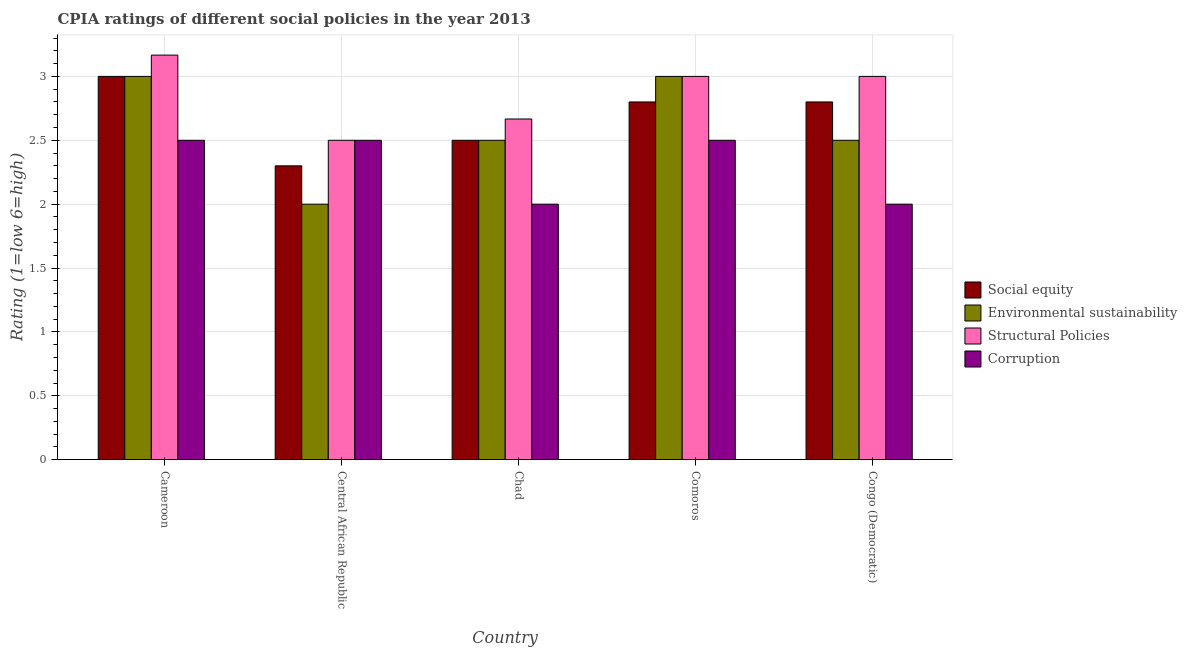How many bars are there on the 3rd tick from the left?
Provide a short and direct response. 4. What is the label of the 3rd group of bars from the left?
Provide a short and direct response. Chad. In how many cases, is the number of bars for a given country not equal to the number of legend labels?
Provide a short and direct response. 0. What is the cpia rating of corruption in Chad?
Keep it short and to the point. 2. In which country was the cpia rating of environmental sustainability maximum?
Offer a very short reply. Cameroon. In which country was the cpia rating of structural policies minimum?
Your response must be concise. Central African Republic. What is the total cpia rating of structural policies in the graph?
Provide a short and direct response. 14.33. What is the difference between the cpia rating of environmental sustainability in Cameroon and that in Congo (Democratic)?
Your answer should be compact. 0.5. What is the difference between the cpia rating of structural policies in Central African Republic and the cpia rating of social equity in Congo (Democratic)?
Make the answer very short. -0.3. What is the average cpia rating of structural policies per country?
Offer a very short reply. 2.87. What is the ratio of the cpia rating of social equity in Cameroon to that in Congo (Democratic)?
Provide a short and direct response. 1.07. Is the difference between the cpia rating of structural policies in Cameroon and Comoros greater than the difference between the cpia rating of social equity in Cameroon and Comoros?
Provide a succinct answer. No. What is the difference between the highest and the second highest cpia rating of structural policies?
Ensure brevity in your answer.  0.17. What is the difference between the highest and the lowest cpia rating of social equity?
Your answer should be very brief. 0.7. In how many countries, is the cpia rating of environmental sustainability greater than the average cpia rating of environmental sustainability taken over all countries?
Provide a succinct answer. 2. What does the 4th bar from the left in Central African Republic represents?
Make the answer very short. Corruption. What does the 3rd bar from the right in Congo (Democratic) represents?
Your answer should be compact. Environmental sustainability. Is it the case that in every country, the sum of the cpia rating of social equity and cpia rating of environmental sustainability is greater than the cpia rating of structural policies?
Your answer should be compact. Yes. How many countries are there in the graph?
Offer a terse response. 5. What is the difference between two consecutive major ticks on the Y-axis?
Keep it short and to the point. 0.5. Does the graph contain any zero values?
Keep it short and to the point. No. How many legend labels are there?
Ensure brevity in your answer.  4. What is the title of the graph?
Your answer should be compact. CPIA ratings of different social policies in the year 2013. What is the label or title of the X-axis?
Provide a succinct answer. Country. What is the Rating (1=low 6=high) in Social equity in Cameroon?
Make the answer very short. 3. What is the Rating (1=low 6=high) of Environmental sustainability in Cameroon?
Offer a very short reply. 3. What is the Rating (1=low 6=high) in Structural Policies in Cameroon?
Make the answer very short. 3.17. What is the Rating (1=low 6=high) of Corruption in Cameroon?
Make the answer very short. 2.5. What is the Rating (1=low 6=high) of Corruption in Central African Republic?
Your answer should be very brief. 2.5. What is the Rating (1=low 6=high) of Social equity in Chad?
Provide a succinct answer. 2.5. What is the Rating (1=low 6=high) of Environmental sustainability in Chad?
Your response must be concise. 2.5. What is the Rating (1=low 6=high) of Structural Policies in Chad?
Your answer should be compact. 2.67. What is the Rating (1=low 6=high) in Environmental sustainability in Comoros?
Offer a very short reply. 3. What is the Rating (1=low 6=high) in Environmental sustainability in Congo (Democratic)?
Make the answer very short. 2.5. What is the Rating (1=low 6=high) in Structural Policies in Congo (Democratic)?
Your answer should be compact. 3. Across all countries, what is the maximum Rating (1=low 6=high) in Environmental sustainability?
Provide a succinct answer. 3. Across all countries, what is the maximum Rating (1=low 6=high) of Structural Policies?
Your answer should be very brief. 3.17. Across all countries, what is the minimum Rating (1=low 6=high) in Structural Policies?
Give a very brief answer. 2.5. Across all countries, what is the minimum Rating (1=low 6=high) in Corruption?
Your response must be concise. 2. What is the total Rating (1=low 6=high) of Environmental sustainability in the graph?
Offer a terse response. 13. What is the total Rating (1=low 6=high) of Structural Policies in the graph?
Make the answer very short. 14.33. What is the total Rating (1=low 6=high) of Corruption in the graph?
Offer a very short reply. 11.5. What is the difference between the Rating (1=low 6=high) in Social equity in Cameroon and that in Central African Republic?
Give a very brief answer. 0.7. What is the difference between the Rating (1=low 6=high) of Environmental sustainability in Cameroon and that in Central African Republic?
Provide a succinct answer. 1. What is the difference between the Rating (1=low 6=high) in Structural Policies in Cameroon and that in Central African Republic?
Offer a terse response. 0.67. What is the difference between the Rating (1=low 6=high) of Corruption in Cameroon and that in Central African Republic?
Give a very brief answer. 0. What is the difference between the Rating (1=low 6=high) of Social equity in Cameroon and that in Chad?
Give a very brief answer. 0.5. What is the difference between the Rating (1=low 6=high) in Structural Policies in Cameroon and that in Chad?
Provide a short and direct response. 0.5. What is the difference between the Rating (1=low 6=high) in Corruption in Cameroon and that in Chad?
Offer a very short reply. 0.5. What is the difference between the Rating (1=low 6=high) in Environmental sustainability in Cameroon and that in Comoros?
Keep it short and to the point. 0. What is the difference between the Rating (1=low 6=high) of Corruption in Cameroon and that in Comoros?
Your answer should be very brief. 0. What is the difference between the Rating (1=low 6=high) in Social equity in Central African Republic and that in Chad?
Provide a succinct answer. -0.2. What is the difference between the Rating (1=low 6=high) of Environmental sustainability in Central African Republic and that in Chad?
Your answer should be very brief. -0.5. What is the difference between the Rating (1=low 6=high) in Structural Policies in Central African Republic and that in Chad?
Make the answer very short. -0.17. What is the difference between the Rating (1=low 6=high) of Corruption in Central African Republic and that in Comoros?
Ensure brevity in your answer.  0. What is the difference between the Rating (1=low 6=high) of Social equity in Central African Republic and that in Congo (Democratic)?
Provide a succinct answer. -0.5. What is the difference between the Rating (1=low 6=high) in Structural Policies in Central African Republic and that in Congo (Democratic)?
Provide a succinct answer. -0.5. What is the difference between the Rating (1=low 6=high) of Corruption in Central African Republic and that in Congo (Democratic)?
Offer a terse response. 0.5. What is the difference between the Rating (1=low 6=high) in Social equity in Chad and that in Comoros?
Offer a very short reply. -0.3. What is the difference between the Rating (1=low 6=high) of Structural Policies in Chad and that in Comoros?
Keep it short and to the point. -0.33. What is the difference between the Rating (1=low 6=high) in Corruption in Chad and that in Comoros?
Your response must be concise. -0.5. What is the difference between the Rating (1=low 6=high) of Environmental sustainability in Chad and that in Congo (Democratic)?
Ensure brevity in your answer.  0. What is the difference between the Rating (1=low 6=high) in Structural Policies in Comoros and that in Congo (Democratic)?
Provide a short and direct response. 0. What is the difference between the Rating (1=low 6=high) of Corruption in Comoros and that in Congo (Democratic)?
Give a very brief answer. 0.5. What is the difference between the Rating (1=low 6=high) in Social equity in Cameroon and the Rating (1=low 6=high) in Environmental sustainability in Central African Republic?
Your answer should be compact. 1. What is the difference between the Rating (1=low 6=high) of Social equity in Cameroon and the Rating (1=low 6=high) of Structural Policies in Central African Republic?
Give a very brief answer. 0.5. What is the difference between the Rating (1=low 6=high) of Social equity in Cameroon and the Rating (1=low 6=high) of Corruption in Central African Republic?
Make the answer very short. 0.5. What is the difference between the Rating (1=low 6=high) in Environmental sustainability in Cameroon and the Rating (1=low 6=high) in Structural Policies in Central African Republic?
Keep it short and to the point. 0.5. What is the difference between the Rating (1=low 6=high) in Environmental sustainability in Cameroon and the Rating (1=low 6=high) in Corruption in Central African Republic?
Your answer should be very brief. 0.5. What is the difference between the Rating (1=low 6=high) in Structural Policies in Cameroon and the Rating (1=low 6=high) in Corruption in Central African Republic?
Provide a succinct answer. 0.67. What is the difference between the Rating (1=low 6=high) of Social equity in Cameroon and the Rating (1=low 6=high) of Environmental sustainability in Chad?
Provide a succinct answer. 0.5. What is the difference between the Rating (1=low 6=high) in Social equity in Cameroon and the Rating (1=low 6=high) in Structural Policies in Chad?
Give a very brief answer. 0.33. What is the difference between the Rating (1=low 6=high) of Social equity in Cameroon and the Rating (1=low 6=high) of Corruption in Chad?
Give a very brief answer. 1. What is the difference between the Rating (1=low 6=high) in Environmental sustainability in Cameroon and the Rating (1=low 6=high) in Structural Policies in Chad?
Offer a very short reply. 0.33. What is the difference between the Rating (1=low 6=high) in Environmental sustainability in Cameroon and the Rating (1=low 6=high) in Corruption in Chad?
Keep it short and to the point. 1. What is the difference between the Rating (1=low 6=high) in Structural Policies in Cameroon and the Rating (1=low 6=high) in Corruption in Chad?
Keep it short and to the point. 1.17. What is the difference between the Rating (1=low 6=high) in Social equity in Cameroon and the Rating (1=low 6=high) in Environmental sustainability in Comoros?
Your answer should be very brief. 0. What is the difference between the Rating (1=low 6=high) in Environmental sustainability in Cameroon and the Rating (1=low 6=high) in Structural Policies in Comoros?
Give a very brief answer. 0. What is the difference between the Rating (1=low 6=high) in Structural Policies in Cameroon and the Rating (1=low 6=high) in Corruption in Comoros?
Your answer should be very brief. 0.67. What is the difference between the Rating (1=low 6=high) in Social equity in Cameroon and the Rating (1=low 6=high) in Structural Policies in Congo (Democratic)?
Provide a short and direct response. 0. What is the difference between the Rating (1=low 6=high) of Environmental sustainability in Cameroon and the Rating (1=low 6=high) of Structural Policies in Congo (Democratic)?
Your answer should be compact. 0. What is the difference between the Rating (1=low 6=high) of Environmental sustainability in Cameroon and the Rating (1=low 6=high) of Corruption in Congo (Democratic)?
Provide a short and direct response. 1. What is the difference between the Rating (1=low 6=high) of Structural Policies in Cameroon and the Rating (1=low 6=high) of Corruption in Congo (Democratic)?
Offer a terse response. 1.17. What is the difference between the Rating (1=low 6=high) in Social equity in Central African Republic and the Rating (1=low 6=high) in Environmental sustainability in Chad?
Offer a very short reply. -0.2. What is the difference between the Rating (1=low 6=high) in Social equity in Central African Republic and the Rating (1=low 6=high) in Structural Policies in Chad?
Offer a terse response. -0.37. What is the difference between the Rating (1=low 6=high) of Social equity in Central African Republic and the Rating (1=low 6=high) of Corruption in Chad?
Your answer should be very brief. 0.3. What is the difference between the Rating (1=low 6=high) of Environmental sustainability in Central African Republic and the Rating (1=low 6=high) of Structural Policies in Chad?
Your answer should be very brief. -0.67. What is the difference between the Rating (1=low 6=high) in Environmental sustainability in Central African Republic and the Rating (1=low 6=high) in Corruption in Chad?
Give a very brief answer. 0. What is the difference between the Rating (1=low 6=high) of Social equity in Central African Republic and the Rating (1=low 6=high) of Structural Policies in Comoros?
Offer a terse response. -0.7. What is the difference between the Rating (1=low 6=high) of Social equity in Central African Republic and the Rating (1=low 6=high) of Corruption in Comoros?
Provide a succinct answer. -0.2. What is the difference between the Rating (1=low 6=high) in Environmental sustainability in Central African Republic and the Rating (1=low 6=high) in Corruption in Comoros?
Your response must be concise. -0.5. What is the difference between the Rating (1=low 6=high) in Structural Policies in Central African Republic and the Rating (1=low 6=high) in Corruption in Comoros?
Provide a succinct answer. 0. What is the difference between the Rating (1=low 6=high) in Social equity in Central African Republic and the Rating (1=low 6=high) in Environmental sustainability in Congo (Democratic)?
Your response must be concise. -0.2. What is the difference between the Rating (1=low 6=high) in Environmental sustainability in Central African Republic and the Rating (1=low 6=high) in Structural Policies in Congo (Democratic)?
Provide a succinct answer. -1. What is the difference between the Rating (1=low 6=high) of Environmental sustainability in Central African Republic and the Rating (1=low 6=high) of Corruption in Congo (Democratic)?
Keep it short and to the point. 0. What is the difference between the Rating (1=low 6=high) in Social equity in Chad and the Rating (1=low 6=high) in Corruption in Comoros?
Your response must be concise. 0. What is the difference between the Rating (1=low 6=high) of Environmental sustainability in Chad and the Rating (1=low 6=high) of Corruption in Comoros?
Your response must be concise. 0. What is the difference between the Rating (1=low 6=high) in Social equity in Chad and the Rating (1=low 6=high) in Environmental sustainability in Congo (Democratic)?
Keep it short and to the point. 0. What is the difference between the Rating (1=low 6=high) of Social equity in Chad and the Rating (1=low 6=high) of Structural Policies in Congo (Democratic)?
Ensure brevity in your answer.  -0.5. What is the difference between the Rating (1=low 6=high) of Structural Policies in Chad and the Rating (1=low 6=high) of Corruption in Congo (Democratic)?
Your answer should be compact. 0.67. What is the difference between the Rating (1=low 6=high) of Social equity in Comoros and the Rating (1=low 6=high) of Structural Policies in Congo (Democratic)?
Make the answer very short. -0.2. What is the difference between the Rating (1=low 6=high) of Social equity in Comoros and the Rating (1=low 6=high) of Corruption in Congo (Democratic)?
Offer a terse response. 0.8. What is the difference between the Rating (1=low 6=high) of Environmental sustainability in Comoros and the Rating (1=low 6=high) of Corruption in Congo (Democratic)?
Provide a short and direct response. 1. What is the difference between the Rating (1=low 6=high) in Structural Policies in Comoros and the Rating (1=low 6=high) in Corruption in Congo (Democratic)?
Offer a terse response. 1. What is the average Rating (1=low 6=high) of Social equity per country?
Offer a terse response. 2.68. What is the average Rating (1=low 6=high) of Environmental sustainability per country?
Provide a succinct answer. 2.6. What is the average Rating (1=low 6=high) in Structural Policies per country?
Provide a short and direct response. 2.87. What is the average Rating (1=low 6=high) of Corruption per country?
Your response must be concise. 2.3. What is the difference between the Rating (1=low 6=high) of Social equity and Rating (1=low 6=high) of Structural Policies in Cameroon?
Offer a terse response. -0.17. What is the difference between the Rating (1=low 6=high) of Environmental sustainability and Rating (1=low 6=high) of Structural Policies in Cameroon?
Provide a succinct answer. -0.17. What is the difference between the Rating (1=low 6=high) of Environmental sustainability and Rating (1=low 6=high) of Corruption in Cameroon?
Ensure brevity in your answer.  0.5. What is the difference between the Rating (1=low 6=high) in Structural Policies and Rating (1=low 6=high) in Corruption in Cameroon?
Make the answer very short. 0.67. What is the difference between the Rating (1=low 6=high) of Social equity and Rating (1=low 6=high) of Environmental sustainability in Central African Republic?
Your answer should be compact. 0.3. What is the difference between the Rating (1=low 6=high) in Environmental sustainability and Rating (1=low 6=high) in Corruption in Central African Republic?
Your answer should be very brief. -0.5. What is the difference between the Rating (1=low 6=high) in Structural Policies and Rating (1=low 6=high) in Corruption in Central African Republic?
Provide a short and direct response. 0. What is the difference between the Rating (1=low 6=high) of Social equity and Rating (1=low 6=high) of Environmental sustainability in Chad?
Keep it short and to the point. 0. What is the difference between the Rating (1=low 6=high) of Environmental sustainability and Rating (1=low 6=high) of Structural Policies in Chad?
Give a very brief answer. -0.17. What is the difference between the Rating (1=low 6=high) in Environmental sustainability and Rating (1=low 6=high) in Corruption in Chad?
Make the answer very short. 0.5. What is the difference between the Rating (1=low 6=high) in Structural Policies and Rating (1=low 6=high) in Corruption in Chad?
Provide a short and direct response. 0.67. What is the difference between the Rating (1=low 6=high) in Social equity and Rating (1=low 6=high) in Structural Policies in Comoros?
Provide a short and direct response. -0.2. What is the difference between the Rating (1=low 6=high) in Social equity and Rating (1=low 6=high) in Corruption in Comoros?
Offer a terse response. 0.3. What is the difference between the Rating (1=low 6=high) of Structural Policies and Rating (1=low 6=high) of Corruption in Comoros?
Give a very brief answer. 0.5. What is the difference between the Rating (1=low 6=high) in Social equity and Rating (1=low 6=high) in Structural Policies in Congo (Democratic)?
Provide a succinct answer. -0.2. What is the difference between the Rating (1=low 6=high) in Environmental sustainability and Rating (1=low 6=high) in Corruption in Congo (Democratic)?
Provide a succinct answer. 0.5. What is the difference between the Rating (1=low 6=high) of Structural Policies and Rating (1=low 6=high) of Corruption in Congo (Democratic)?
Your response must be concise. 1. What is the ratio of the Rating (1=low 6=high) of Social equity in Cameroon to that in Central African Republic?
Your response must be concise. 1.3. What is the ratio of the Rating (1=low 6=high) in Environmental sustainability in Cameroon to that in Central African Republic?
Keep it short and to the point. 1.5. What is the ratio of the Rating (1=low 6=high) in Structural Policies in Cameroon to that in Central African Republic?
Give a very brief answer. 1.27. What is the ratio of the Rating (1=low 6=high) in Corruption in Cameroon to that in Central African Republic?
Your answer should be compact. 1. What is the ratio of the Rating (1=low 6=high) in Social equity in Cameroon to that in Chad?
Provide a succinct answer. 1.2. What is the ratio of the Rating (1=low 6=high) of Environmental sustainability in Cameroon to that in Chad?
Your answer should be compact. 1.2. What is the ratio of the Rating (1=low 6=high) in Structural Policies in Cameroon to that in Chad?
Your answer should be compact. 1.19. What is the ratio of the Rating (1=low 6=high) of Corruption in Cameroon to that in Chad?
Make the answer very short. 1.25. What is the ratio of the Rating (1=low 6=high) in Social equity in Cameroon to that in Comoros?
Your answer should be compact. 1.07. What is the ratio of the Rating (1=low 6=high) in Environmental sustainability in Cameroon to that in Comoros?
Keep it short and to the point. 1. What is the ratio of the Rating (1=low 6=high) in Structural Policies in Cameroon to that in Comoros?
Your response must be concise. 1.06. What is the ratio of the Rating (1=low 6=high) in Social equity in Cameroon to that in Congo (Democratic)?
Your answer should be very brief. 1.07. What is the ratio of the Rating (1=low 6=high) in Structural Policies in Cameroon to that in Congo (Democratic)?
Make the answer very short. 1.06. What is the ratio of the Rating (1=low 6=high) in Corruption in Cameroon to that in Congo (Democratic)?
Keep it short and to the point. 1.25. What is the ratio of the Rating (1=low 6=high) of Social equity in Central African Republic to that in Chad?
Ensure brevity in your answer.  0.92. What is the ratio of the Rating (1=low 6=high) of Environmental sustainability in Central African Republic to that in Chad?
Your response must be concise. 0.8. What is the ratio of the Rating (1=low 6=high) of Social equity in Central African Republic to that in Comoros?
Give a very brief answer. 0.82. What is the ratio of the Rating (1=low 6=high) in Corruption in Central African Republic to that in Comoros?
Your answer should be very brief. 1. What is the ratio of the Rating (1=low 6=high) in Social equity in Central African Republic to that in Congo (Democratic)?
Give a very brief answer. 0.82. What is the ratio of the Rating (1=low 6=high) in Structural Policies in Central African Republic to that in Congo (Democratic)?
Offer a very short reply. 0.83. What is the ratio of the Rating (1=low 6=high) of Corruption in Central African Republic to that in Congo (Democratic)?
Provide a succinct answer. 1.25. What is the ratio of the Rating (1=low 6=high) in Social equity in Chad to that in Comoros?
Offer a very short reply. 0.89. What is the ratio of the Rating (1=low 6=high) in Structural Policies in Chad to that in Comoros?
Provide a succinct answer. 0.89. What is the ratio of the Rating (1=low 6=high) in Social equity in Chad to that in Congo (Democratic)?
Keep it short and to the point. 0.89. What is the ratio of the Rating (1=low 6=high) in Structural Policies in Chad to that in Congo (Democratic)?
Provide a short and direct response. 0.89. What is the ratio of the Rating (1=low 6=high) in Social equity in Comoros to that in Congo (Democratic)?
Your answer should be very brief. 1. What is the ratio of the Rating (1=low 6=high) in Structural Policies in Comoros to that in Congo (Democratic)?
Give a very brief answer. 1. What is the ratio of the Rating (1=low 6=high) of Corruption in Comoros to that in Congo (Democratic)?
Offer a terse response. 1.25. What is the difference between the highest and the second highest Rating (1=low 6=high) of Corruption?
Your answer should be compact. 0. What is the difference between the highest and the lowest Rating (1=low 6=high) of Social equity?
Ensure brevity in your answer.  0.7. What is the difference between the highest and the lowest Rating (1=low 6=high) of Environmental sustainability?
Make the answer very short. 1. What is the difference between the highest and the lowest Rating (1=low 6=high) of Structural Policies?
Keep it short and to the point. 0.67. What is the difference between the highest and the lowest Rating (1=low 6=high) in Corruption?
Give a very brief answer. 0.5. 